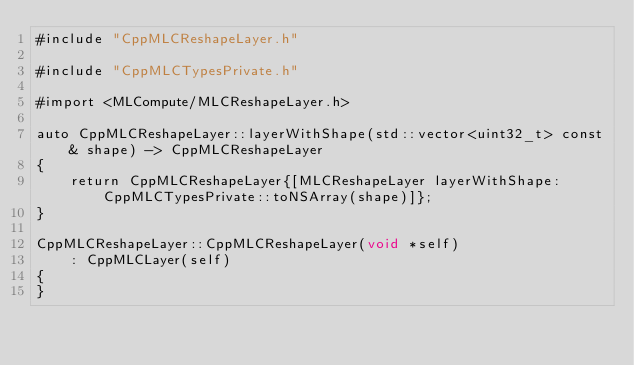<code> <loc_0><loc_0><loc_500><loc_500><_ObjectiveC_>#include "CppMLCReshapeLayer.h"

#include "CppMLCTypesPrivate.h"

#import <MLCompute/MLCReshapeLayer.h>

auto CppMLCReshapeLayer::layerWithShape(std::vector<uint32_t> const& shape) -> CppMLCReshapeLayer
{
    return CppMLCReshapeLayer{[MLCReshapeLayer layerWithShape:CppMLCTypesPrivate::toNSArray(shape)]};
}

CppMLCReshapeLayer::CppMLCReshapeLayer(void *self)
    : CppMLCLayer(self)
{
}
</code> 